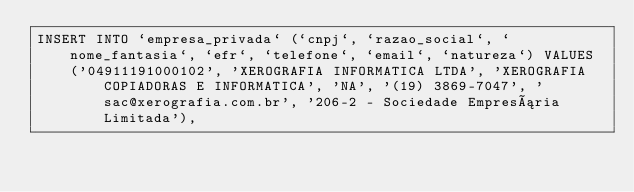<code> <loc_0><loc_0><loc_500><loc_500><_SQL_>INSERT INTO `empresa_privada` (`cnpj`, `razao_social`, `nome_fantasia`, `efr`, `telefone`, `email`, `natureza`) VALUES
	('04911191000102', 'XEROGRAFIA INFORMATICA LTDA', 'XEROGRAFIA COPIADORAS E INFORMATICA', 'NA', '(19) 3869-7047', 'sac@xerografia.com.br', '206-2 - Sociedade Empresária Limitada'),</code> 